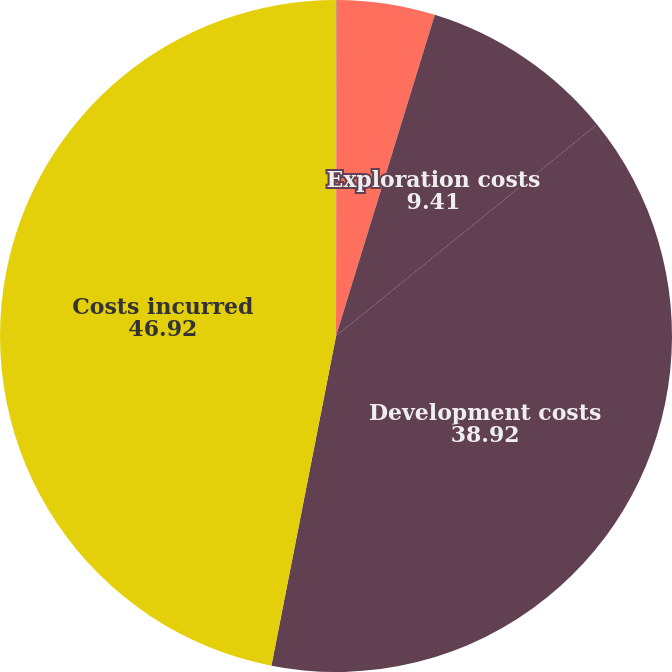<chart> <loc_0><loc_0><loc_500><loc_500><pie_chart><fcel>Proved properties<fcel>Unproved properties<fcel>Exploration costs<fcel>Development costs<fcel>Costs incurred<nl><fcel>0.03%<fcel>4.72%<fcel>9.41%<fcel>38.92%<fcel>46.92%<nl></chart> 